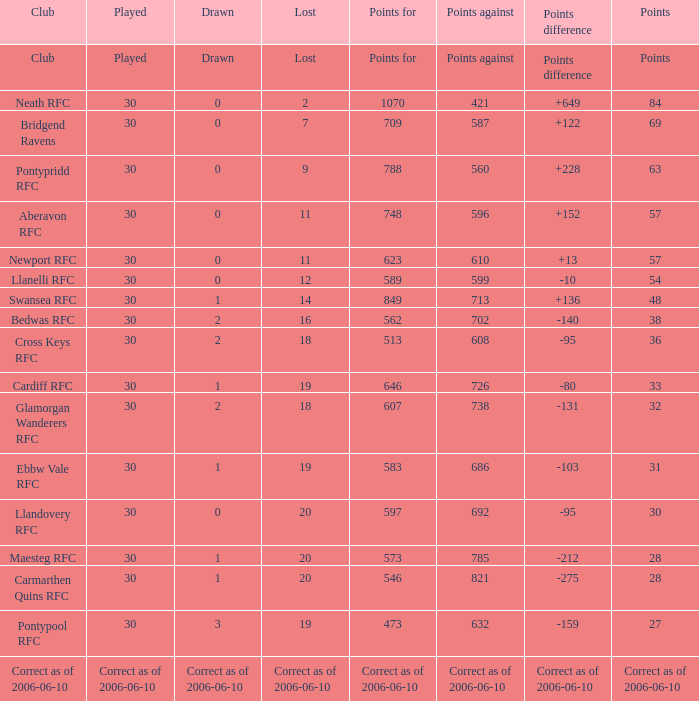What is represented, when points against amounts to "686"? 1.0. 